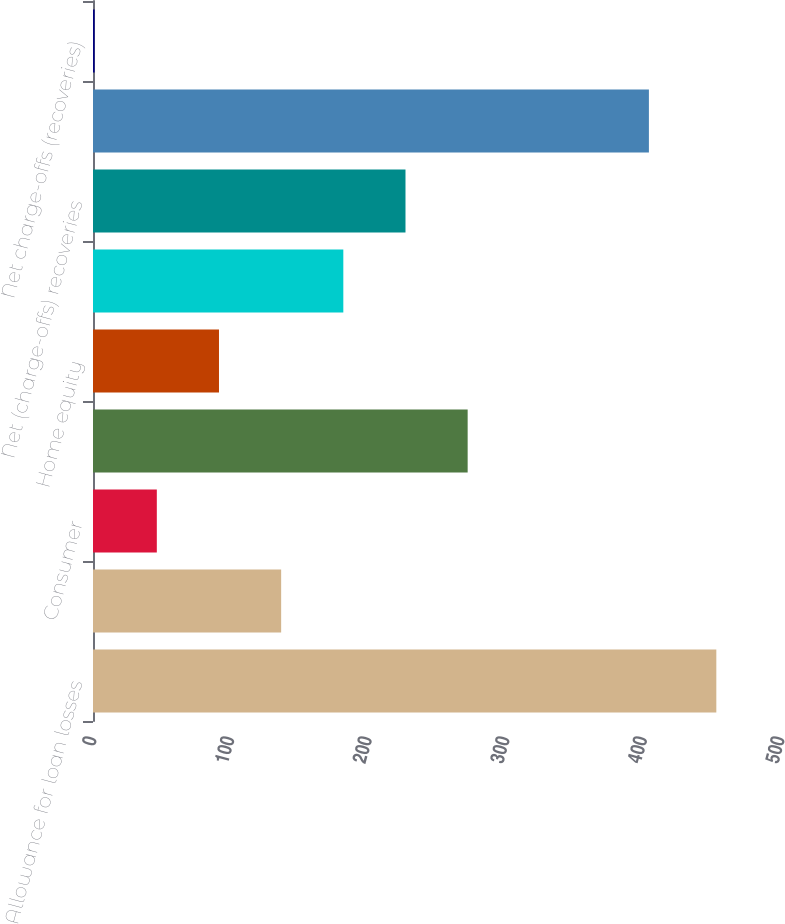Convert chart to OTSL. <chart><loc_0><loc_0><loc_500><loc_500><bar_chart><fcel>Allowance for loan losses<fcel>Provision (benefit) for loan<fcel>Consumer<fcel>Total charge-offs<fcel>Home equity<fcel>Total recoveries<fcel>Net (charge-offs) recoveries<fcel>Allowance for loan losses end<fcel>Net charge-offs (recoveries)<nl><fcel>453<fcel>136.74<fcel>46.38<fcel>272.28<fcel>91.56<fcel>181.92<fcel>227.1<fcel>404<fcel>1.2<nl></chart> 